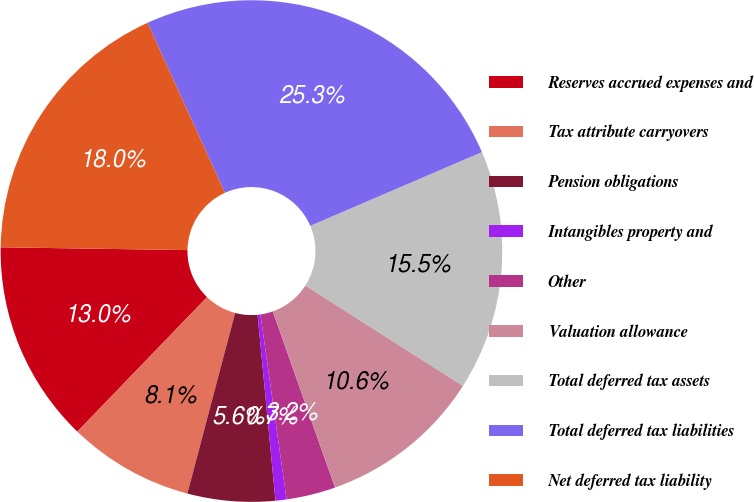Convert chart. <chart><loc_0><loc_0><loc_500><loc_500><pie_chart><fcel>Reserves accrued expenses and<fcel>Tax attribute carryovers<fcel>Pension obligations<fcel>Intangibles property and<fcel>Other<fcel>Valuation allowance<fcel>Total deferred tax assets<fcel>Total deferred tax liabilities<fcel>Net deferred tax liability<nl><fcel>13.03%<fcel>8.1%<fcel>5.64%<fcel>0.71%<fcel>3.17%<fcel>10.56%<fcel>15.49%<fcel>25.35%<fcel>17.96%<nl></chart> 